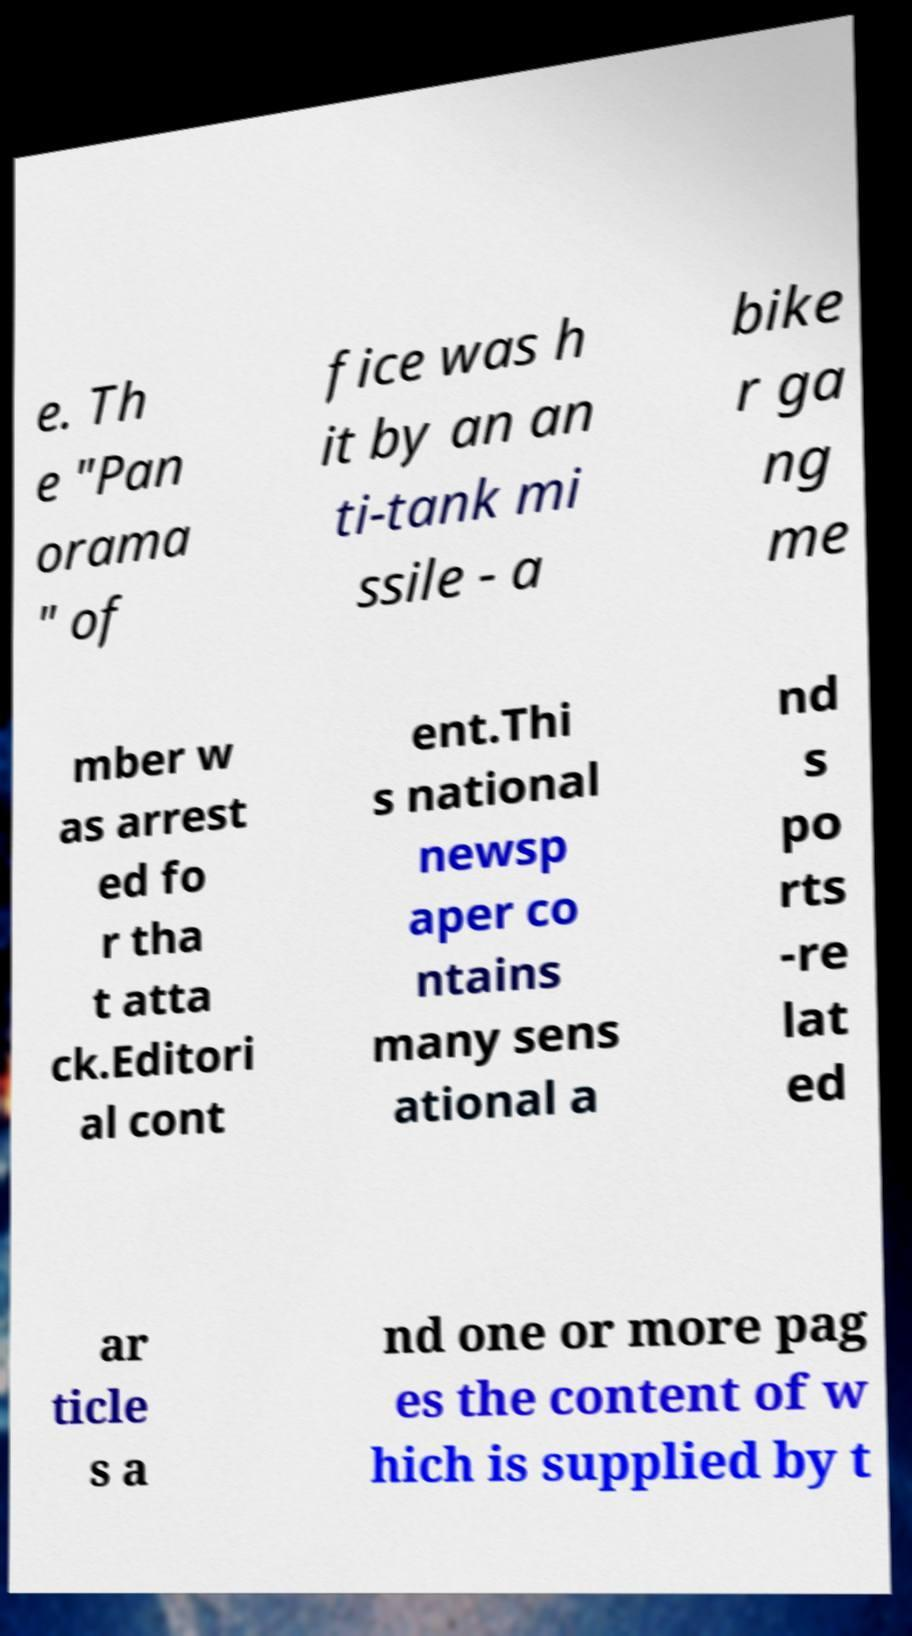Can you read and provide the text displayed in the image?This photo seems to have some interesting text. Can you extract and type it out for me? e. Th e "Pan orama " of fice was h it by an an ti-tank mi ssile - a bike r ga ng me mber w as arrest ed fo r tha t atta ck.Editori al cont ent.Thi s national newsp aper co ntains many sens ational a nd s po rts -re lat ed ar ticle s a nd one or more pag es the content of w hich is supplied by t 